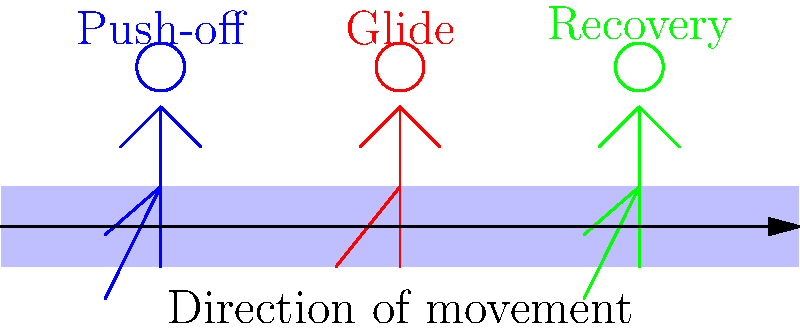In an efficient hockey skating stride, which phase of the stride cycle generates the most forward propulsion, and why is this phase crucial for maximizing speed on the ice? To understand the biomechanics of an efficient skating stride, let's break down the three main phases illustrated in the diagram:

1. Push-off phase (blue figure):
   - The skater's leg is extended behind the body at an angle.
   - This phase generates the most forward propulsion.
   - The skater pushes against the ice, applying force in a diagonal direction.
   - The angle of the push allows for both vertical and horizontal force components.

2. Glide phase (red figure):
   - The skater's body is in an upright position with legs close together.
   - This phase allows the skater to maintain speed with minimal energy expenditure.
   - The reduced friction of the skate blade on ice enables efficient gliding.

3. Recovery phase (green figure):
   - The skater's leg is lifted and brought forward.
   - This phase prepares the leg for the next push-off.
   - Minimal propulsion is generated during this phase.

The push-off phase is crucial for maximizing speed because:

a) It's the only phase where significant force is applied to the ice.
b) The angled push allows for optimal force transfer into forward motion.
c) The force applied during push-off directly correlates to the speed achieved during the glide phase.
d) Efficient push-off technique minimizes energy loss and maximizes power output.

To optimize the push-off phase, skaters like William Stromgrem focus on:
- Maintaining a low body position to increase the push angle.
- Fully extending the pushing leg for maximum force application.
- Coordinating upper body movement to enhance overall power generation.

By mastering the push-off phase, skaters can achieve higher speeds and maintain them more efficiently throughout the stride cycle.
Answer: Push-off phase; generates most propulsion through angled force application. 